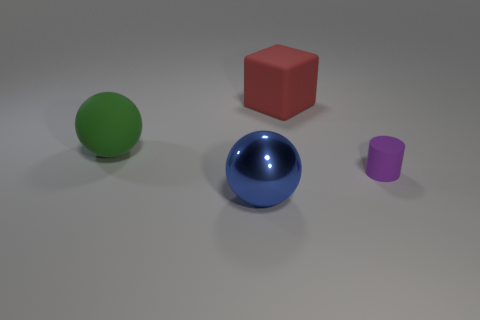What number of large rubber blocks are in front of the big ball in front of the tiny purple matte cylinder?
Your answer should be compact. 0. What number of large green matte things are the same shape as the blue thing?
Keep it short and to the point. 1. How many green balls are there?
Make the answer very short. 1. What is the color of the big rubber object on the right side of the large shiny thing?
Your answer should be compact. Red. There is a object in front of the matte thing right of the large rubber cube; what color is it?
Your answer should be compact. Blue. The matte block that is the same size as the blue sphere is what color?
Offer a very short reply. Red. How many things are in front of the red matte object and behind the big blue ball?
Your answer should be compact. 2. What material is the thing that is on the left side of the rubber cylinder and to the right of the blue metallic ball?
Give a very brief answer. Rubber. Are there fewer big red objects that are behind the blue object than green matte objects that are in front of the big red matte block?
Provide a succinct answer. No. There is a sphere that is the same material as the purple thing; what is its size?
Offer a terse response. Large. 